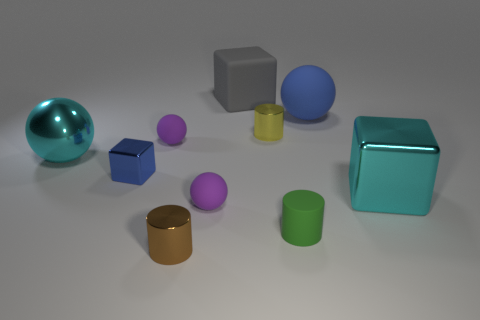Subtract 2 balls. How many balls are left? 2 Subtract all green spheres. Subtract all blue cylinders. How many spheres are left? 4 Subtract all spheres. How many objects are left? 6 Add 7 small brown objects. How many small brown objects are left? 8 Add 7 big blue cubes. How many big blue cubes exist? 7 Subtract 1 blue cubes. How many objects are left? 9 Subtract all big green matte blocks. Subtract all cylinders. How many objects are left? 7 